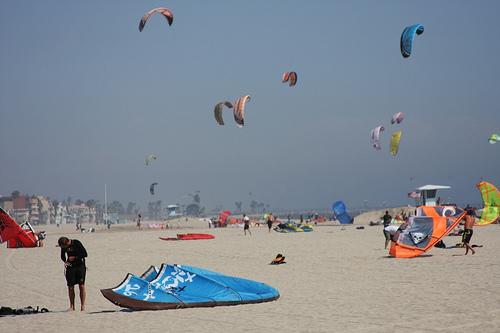What country does the emblem on the chute represent?
Keep it brief. Usa. How many kites are in the sky?
Short answer required. 10. What kind of kites are these?
Write a very short answer. Large. Does the surfboard appear heavy?
Answer briefly. No. Where was this taken?
Give a very brief answer. Beach. What are the people standing on?
Quick response, please. Sand. Are there any tents in this picture?
Short answer required. No. What are the people flying in the air?
Give a very brief answer. Kites. Where was the picture taken?
Short answer required. Beach. 